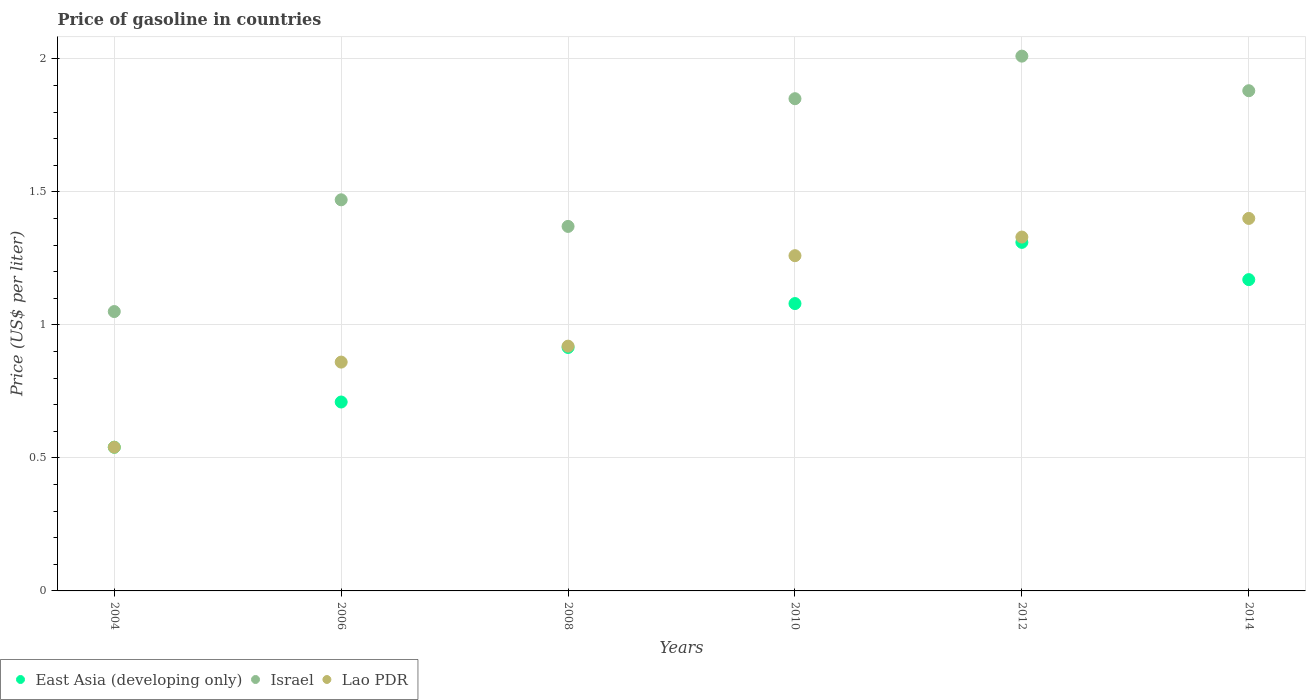How many different coloured dotlines are there?
Offer a terse response. 3. Is the number of dotlines equal to the number of legend labels?
Your answer should be compact. Yes. What is the price of gasoline in Lao PDR in 2014?
Provide a short and direct response. 1.4. Across all years, what is the maximum price of gasoline in Israel?
Offer a terse response. 2.01. In which year was the price of gasoline in East Asia (developing only) maximum?
Ensure brevity in your answer.  2012. In which year was the price of gasoline in East Asia (developing only) minimum?
Provide a succinct answer. 2004. What is the total price of gasoline in Lao PDR in the graph?
Keep it short and to the point. 6.31. What is the difference between the price of gasoline in East Asia (developing only) in 2012 and that in 2014?
Provide a succinct answer. 0.14. What is the difference between the price of gasoline in Lao PDR in 2006 and the price of gasoline in East Asia (developing only) in 2012?
Provide a short and direct response. -0.45. What is the average price of gasoline in Israel per year?
Ensure brevity in your answer.  1.6. In the year 2014, what is the difference between the price of gasoline in East Asia (developing only) and price of gasoline in Lao PDR?
Offer a very short reply. -0.23. What is the ratio of the price of gasoline in Lao PDR in 2006 to that in 2012?
Your response must be concise. 0.65. Is the difference between the price of gasoline in East Asia (developing only) in 2006 and 2014 greater than the difference between the price of gasoline in Lao PDR in 2006 and 2014?
Provide a succinct answer. Yes. What is the difference between the highest and the second highest price of gasoline in Israel?
Ensure brevity in your answer.  0.13. What is the difference between the highest and the lowest price of gasoline in Israel?
Ensure brevity in your answer.  0.96. Is it the case that in every year, the sum of the price of gasoline in East Asia (developing only) and price of gasoline in Lao PDR  is greater than the price of gasoline in Israel?
Give a very brief answer. Yes. Does the price of gasoline in Lao PDR monotonically increase over the years?
Provide a short and direct response. Yes. Is the price of gasoline in East Asia (developing only) strictly greater than the price of gasoline in Israel over the years?
Ensure brevity in your answer.  No. Is the price of gasoline in Lao PDR strictly less than the price of gasoline in East Asia (developing only) over the years?
Offer a very short reply. No. How many years are there in the graph?
Your answer should be very brief. 6. What is the difference between two consecutive major ticks on the Y-axis?
Make the answer very short. 0.5. Does the graph contain grids?
Your answer should be very brief. Yes. How many legend labels are there?
Your answer should be very brief. 3. How are the legend labels stacked?
Provide a short and direct response. Horizontal. What is the title of the graph?
Keep it short and to the point. Price of gasoline in countries. Does "Guinea-Bissau" appear as one of the legend labels in the graph?
Offer a terse response. No. What is the label or title of the X-axis?
Your answer should be very brief. Years. What is the label or title of the Y-axis?
Keep it short and to the point. Price (US$ per liter). What is the Price (US$ per liter) of East Asia (developing only) in 2004?
Your response must be concise. 0.54. What is the Price (US$ per liter) of Israel in 2004?
Give a very brief answer. 1.05. What is the Price (US$ per liter) in Lao PDR in 2004?
Provide a succinct answer. 0.54. What is the Price (US$ per liter) in East Asia (developing only) in 2006?
Keep it short and to the point. 0.71. What is the Price (US$ per liter) in Israel in 2006?
Your response must be concise. 1.47. What is the Price (US$ per liter) of Lao PDR in 2006?
Provide a short and direct response. 0.86. What is the Price (US$ per liter) in East Asia (developing only) in 2008?
Provide a short and direct response. 0.92. What is the Price (US$ per liter) in Israel in 2008?
Give a very brief answer. 1.37. What is the Price (US$ per liter) of East Asia (developing only) in 2010?
Ensure brevity in your answer.  1.08. What is the Price (US$ per liter) of Israel in 2010?
Your answer should be very brief. 1.85. What is the Price (US$ per liter) of Lao PDR in 2010?
Ensure brevity in your answer.  1.26. What is the Price (US$ per liter) in East Asia (developing only) in 2012?
Keep it short and to the point. 1.31. What is the Price (US$ per liter) of Israel in 2012?
Provide a succinct answer. 2.01. What is the Price (US$ per liter) in Lao PDR in 2012?
Provide a short and direct response. 1.33. What is the Price (US$ per liter) in East Asia (developing only) in 2014?
Provide a succinct answer. 1.17. What is the Price (US$ per liter) in Israel in 2014?
Provide a succinct answer. 1.88. Across all years, what is the maximum Price (US$ per liter) of East Asia (developing only)?
Provide a succinct answer. 1.31. Across all years, what is the maximum Price (US$ per liter) of Israel?
Your response must be concise. 2.01. Across all years, what is the minimum Price (US$ per liter) of East Asia (developing only)?
Offer a very short reply. 0.54. Across all years, what is the minimum Price (US$ per liter) of Lao PDR?
Offer a very short reply. 0.54. What is the total Price (US$ per liter) of East Asia (developing only) in the graph?
Make the answer very short. 5.72. What is the total Price (US$ per liter) of Israel in the graph?
Make the answer very short. 9.63. What is the total Price (US$ per liter) in Lao PDR in the graph?
Make the answer very short. 6.31. What is the difference between the Price (US$ per liter) of East Asia (developing only) in 2004 and that in 2006?
Offer a terse response. -0.17. What is the difference between the Price (US$ per liter) in Israel in 2004 and that in 2006?
Provide a succinct answer. -0.42. What is the difference between the Price (US$ per liter) in Lao PDR in 2004 and that in 2006?
Give a very brief answer. -0.32. What is the difference between the Price (US$ per liter) of East Asia (developing only) in 2004 and that in 2008?
Your response must be concise. -0.38. What is the difference between the Price (US$ per liter) in Israel in 2004 and that in 2008?
Your answer should be very brief. -0.32. What is the difference between the Price (US$ per liter) in Lao PDR in 2004 and that in 2008?
Keep it short and to the point. -0.38. What is the difference between the Price (US$ per liter) of East Asia (developing only) in 2004 and that in 2010?
Your answer should be compact. -0.54. What is the difference between the Price (US$ per liter) in Israel in 2004 and that in 2010?
Ensure brevity in your answer.  -0.8. What is the difference between the Price (US$ per liter) of Lao PDR in 2004 and that in 2010?
Provide a succinct answer. -0.72. What is the difference between the Price (US$ per liter) in East Asia (developing only) in 2004 and that in 2012?
Provide a short and direct response. -0.77. What is the difference between the Price (US$ per liter) in Israel in 2004 and that in 2012?
Ensure brevity in your answer.  -0.96. What is the difference between the Price (US$ per liter) in Lao PDR in 2004 and that in 2012?
Your response must be concise. -0.79. What is the difference between the Price (US$ per liter) of East Asia (developing only) in 2004 and that in 2014?
Give a very brief answer. -0.63. What is the difference between the Price (US$ per liter) in Israel in 2004 and that in 2014?
Your response must be concise. -0.83. What is the difference between the Price (US$ per liter) of Lao PDR in 2004 and that in 2014?
Offer a terse response. -0.86. What is the difference between the Price (US$ per liter) of East Asia (developing only) in 2006 and that in 2008?
Keep it short and to the point. -0.2. What is the difference between the Price (US$ per liter) in Lao PDR in 2006 and that in 2008?
Give a very brief answer. -0.06. What is the difference between the Price (US$ per liter) in East Asia (developing only) in 2006 and that in 2010?
Your answer should be very brief. -0.37. What is the difference between the Price (US$ per liter) in Israel in 2006 and that in 2010?
Provide a short and direct response. -0.38. What is the difference between the Price (US$ per liter) of Israel in 2006 and that in 2012?
Your response must be concise. -0.54. What is the difference between the Price (US$ per liter) in Lao PDR in 2006 and that in 2012?
Your answer should be compact. -0.47. What is the difference between the Price (US$ per liter) of East Asia (developing only) in 2006 and that in 2014?
Your answer should be compact. -0.46. What is the difference between the Price (US$ per liter) of Israel in 2006 and that in 2014?
Provide a short and direct response. -0.41. What is the difference between the Price (US$ per liter) of Lao PDR in 2006 and that in 2014?
Provide a short and direct response. -0.54. What is the difference between the Price (US$ per liter) of East Asia (developing only) in 2008 and that in 2010?
Your response must be concise. -0.17. What is the difference between the Price (US$ per liter) of Israel in 2008 and that in 2010?
Your response must be concise. -0.48. What is the difference between the Price (US$ per liter) in Lao PDR in 2008 and that in 2010?
Provide a succinct answer. -0.34. What is the difference between the Price (US$ per liter) in East Asia (developing only) in 2008 and that in 2012?
Give a very brief answer. -0.4. What is the difference between the Price (US$ per liter) of Israel in 2008 and that in 2012?
Offer a terse response. -0.64. What is the difference between the Price (US$ per liter) of Lao PDR in 2008 and that in 2012?
Make the answer very short. -0.41. What is the difference between the Price (US$ per liter) in East Asia (developing only) in 2008 and that in 2014?
Ensure brevity in your answer.  -0.26. What is the difference between the Price (US$ per liter) of Israel in 2008 and that in 2014?
Offer a terse response. -0.51. What is the difference between the Price (US$ per liter) in Lao PDR in 2008 and that in 2014?
Keep it short and to the point. -0.48. What is the difference between the Price (US$ per liter) in East Asia (developing only) in 2010 and that in 2012?
Ensure brevity in your answer.  -0.23. What is the difference between the Price (US$ per liter) in Israel in 2010 and that in 2012?
Your response must be concise. -0.16. What is the difference between the Price (US$ per liter) of Lao PDR in 2010 and that in 2012?
Provide a short and direct response. -0.07. What is the difference between the Price (US$ per liter) in East Asia (developing only) in 2010 and that in 2014?
Your answer should be compact. -0.09. What is the difference between the Price (US$ per liter) of Israel in 2010 and that in 2014?
Offer a very short reply. -0.03. What is the difference between the Price (US$ per liter) of Lao PDR in 2010 and that in 2014?
Provide a succinct answer. -0.14. What is the difference between the Price (US$ per liter) of East Asia (developing only) in 2012 and that in 2014?
Keep it short and to the point. 0.14. What is the difference between the Price (US$ per liter) in Israel in 2012 and that in 2014?
Offer a very short reply. 0.13. What is the difference between the Price (US$ per liter) of Lao PDR in 2012 and that in 2014?
Your answer should be compact. -0.07. What is the difference between the Price (US$ per liter) of East Asia (developing only) in 2004 and the Price (US$ per liter) of Israel in 2006?
Provide a succinct answer. -0.93. What is the difference between the Price (US$ per liter) in East Asia (developing only) in 2004 and the Price (US$ per liter) in Lao PDR in 2006?
Your answer should be very brief. -0.32. What is the difference between the Price (US$ per liter) of Israel in 2004 and the Price (US$ per liter) of Lao PDR in 2006?
Your answer should be compact. 0.19. What is the difference between the Price (US$ per liter) of East Asia (developing only) in 2004 and the Price (US$ per liter) of Israel in 2008?
Give a very brief answer. -0.83. What is the difference between the Price (US$ per liter) in East Asia (developing only) in 2004 and the Price (US$ per liter) in Lao PDR in 2008?
Make the answer very short. -0.38. What is the difference between the Price (US$ per liter) in Israel in 2004 and the Price (US$ per liter) in Lao PDR in 2008?
Offer a very short reply. 0.13. What is the difference between the Price (US$ per liter) in East Asia (developing only) in 2004 and the Price (US$ per liter) in Israel in 2010?
Your answer should be compact. -1.31. What is the difference between the Price (US$ per liter) in East Asia (developing only) in 2004 and the Price (US$ per liter) in Lao PDR in 2010?
Offer a very short reply. -0.72. What is the difference between the Price (US$ per liter) in Israel in 2004 and the Price (US$ per liter) in Lao PDR in 2010?
Your answer should be compact. -0.21. What is the difference between the Price (US$ per liter) in East Asia (developing only) in 2004 and the Price (US$ per liter) in Israel in 2012?
Keep it short and to the point. -1.47. What is the difference between the Price (US$ per liter) of East Asia (developing only) in 2004 and the Price (US$ per liter) of Lao PDR in 2012?
Your response must be concise. -0.79. What is the difference between the Price (US$ per liter) in Israel in 2004 and the Price (US$ per liter) in Lao PDR in 2012?
Give a very brief answer. -0.28. What is the difference between the Price (US$ per liter) of East Asia (developing only) in 2004 and the Price (US$ per liter) of Israel in 2014?
Make the answer very short. -1.34. What is the difference between the Price (US$ per liter) in East Asia (developing only) in 2004 and the Price (US$ per liter) in Lao PDR in 2014?
Keep it short and to the point. -0.86. What is the difference between the Price (US$ per liter) in Israel in 2004 and the Price (US$ per liter) in Lao PDR in 2014?
Make the answer very short. -0.35. What is the difference between the Price (US$ per liter) in East Asia (developing only) in 2006 and the Price (US$ per liter) in Israel in 2008?
Your answer should be compact. -0.66. What is the difference between the Price (US$ per liter) of East Asia (developing only) in 2006 and the Price (US$ per liter) of Lao PDR in 2008?
Your answer should be compact. -0.21. What is the difference between the Price (US$ per liter) in Israel in 2006 and the Price (US$ per liter) in Lao PDR in 2008?
Provide a succinct answer. 0.55. What is the difference between the Price (US$ per liter) in East Asia (developing only) in 2006 and the Price (US$ per liter) in Israel in 2010?
Your answer should be very brief. -1.14. What is the difference between the Price (US$ per liter) of East Asia (developing only) in 2006 and the Price (US$ per liter) of Lao PDR in 2010?
Give a very brief answer. -0.55. What is the difference between the Price (US$ per liter) in Israel in 2006 and the Price (US$ per liter) in Lao PDR in 2010?
Your answer should be very brief. 0.21. What is the difference between the Price (US$ per liter) in East Asia (developing only) in 2006 and the Price (US$ per liter) in Israel in 2012?
Make the answer very short. -1.3. What is the difference between the Price (US$ per liter) in East Asia (developing only) in 2006 and the Price (US$ per liter) in Lao PDR in 2012?
Keep it short and to the point. -0.62. What is the difference between the Price (US$ per liter) of Israel in 2006 and the Price (US$ per liter) of Lao PDR in 2012?
Provide a short and direct response. 0.14. What is the difference between the Price (US$ per liter) of East Asia (developing only) in 2006 and the Price (US$ per liter) of Israel in 2014?
Ensure brevity in your answer.  -1.17. What is the difference between the Price (US$ per liter) in East Asia (developing only) in 2006 and the Price (US$ per liter) in Lao PDR in 2014?
Your response must be concise. -0.69. What is the difference between the Price (US$ per liter) of Israel in 2006 and the Price (US$ per liter) of Lao PDR in 2014?
Offer a very short reply. 0.07. What is the difference between the Price (US$ per liter) in East Asia (developing only) in 2008 and the Price (US$ per liter) in Israel in 2010?
Offer a very short reply. -0.94. What is the difference between the Price (US$ per liter) of East Asia (developing only) in 2008 and the Price (US$ per liter) of Lao PDR in 2010?
Make the answer very short. -0.34. What is the difference between the Price (US$ per liter) in Israel in 2008 and the Price (US$ per liter) in Lao PDR in 2010?
Provide a short and direct response. 0.11. What is the difference between the Price (US$ per liter) of East Asia (developing only) in 2008 and the Price (US$ per liter) of Israel in 2012?
Make the answer very short. -1.09. What is the difference between the Price (US$ per liter) of East Asia (developing only) in 2008 and the Price (US$ per liter) of Lao PDR in 2012?
Make the answer very short. -0.41. What is the difference between the Price (US$ per liter) of East Asia (developing only) in 2008 and the Price (US$ per liter) of Israel in 2014?
Your response must be concise. -0.96. What is the difference between the Price (US$ per liter) in East Asia (developing only) in 2008 and the Price (US$ per liter) in Lao PDR in 2014?
Provide a short and direct response. -0.48. What is the difference between the Price (US$ per liter) of Israel in 2008 and the Price (US$ per liter) of Lao PDR in 2014?
Your answer should be very brief. -0.03. What is the difference between the Price (US$ per liter) of East Asia (developing only) in 2010 and the Price (US$ per liter) of Israel in 2012?
Make the answer very short. -0.93. What is the difference between the Price (US$ per liter) in East Asia (developing only) in 2010 and the Price (US$ per liter) in Lao PDR in 2012?
Give a very brief answer. -0.25. What is the difference between the Price (US$ per liter) in Israel in 2010 and the Price (US$ per liter) in Lao PDR in 2012?
Provide a succinct answer. 0.52. What is the difference between the Price (US$ per liter) of East Asia (developing only) in 2010 and the Price (US$ per liter) of Israel in 2014?
Keep it short and to the point. -0.8. What is the difference between the Price (US$ per liter) in East Asia (developing only) in 2010 and the Price (US$ per liter) in Lao PDR in 2014?
Give a very brief answer. -0.32. What is the difference between the Price (US$ per liter) of Israel in 2010 and the Price (US$ per liter) of Lao PDR in 2014?
Offer a terse response. 0.45. What is the difference between the Price (US$ per liter) in East Asia (developing only) in 2012 and the Price (US$ per liter) in Israel in 2014?
Your answer should be very brief. -0.57. What is the difference between the Price (US$ per liter) in East Asia (developing only) in 2012 and the Price (US$ per liter) in Lao PDR in 2014?
Make the answer very short. -0.09. What is the difference between the Price (US$ per liter) in Israel in 2012 and the Price (US$ per liter) in Lao PDR in 2014?
Give a very brief answer. 0.61. What is the average Price (US$ per liter) in East Asia (developing only) per year?
Keep it short and to the point. 0.95. What is the average Price (US$ per liter) of Israel per year?
Provide a short and direct response. 1.6. What is the average Price (US$ per liter) in Lao PDR per year?
Your answer should be compact. 1.05. In the year 2004, what is the difference between the Price (US$ per liter) in East Asia (developing only) and Price (US$ per liter) in Israel?
Make the answer very short. -0.51. In the year 2004, what is the difference between the Price (US$ per liter) in Israel and Price (US$ per liter) in Lao PDR?
Make the answer very short. 0.51. In the year 2006, what is the difference between the Price (US$ per liter) of East Asia (developing only) and Price (US$ per liter) of Israel?
Keep it short and to the point. -0.76. In the year 2006, what is the difference between the Price (US$ per liter) of East Asia (developing only) and Price (US$ per liter) of Lao PDR?
Offer a very short reply. -0.15. In the year 2006, what is the difference between the Price (US$ per liter) in Israel and Price (US$ per liter) in Lao PDR?
Provide a succinct answer. 0.61. In the year 2008, what is the difference between the Price (US$ per liter) in East Asia (developing only) and Price (US$ per liter) in Israel?
Keep it short and to the point. -0.46. In the year 2008, what is the difference between the Price (US$ per liter) in East Asia (developing only) and Price (US$ per liter) in Lao PDR?
Provide a succinct answer. -0.01. In the year 2008, what is the difference between the Price (US$ per liter) of Israel and Price (US$ per liter) of Lao PDR?
Give a very brief answer. 0.45. In the year 2010, what is the difference between the Price (US$ per liter) in East Asia (developing only) and Price (US$ per liter) in Israel?
Ensure brevity in your answer.  -0.77. In the year 2010, what is the difference between the Price (US$ per liter) in East Asia (developing only) and Price (US$ per liter) in Lao PDR?
Ensure brevity in your answer.  -0.18. In the year 2010, what is the difference between the Price (US$ per liter) of Israel and Price (US$ per liter) of Lao PDR?
Give a very brief answer. 0.59. In the year 2012, what is the difference between the Price (US$ per liter) in East Asia (developing only) and Price (US$ per liter) in Lao PDR?
Your answer should be very brief. -0.02. In the year 2012, what is the difference between the Price (US$ per liter) in Israel and Price (US$ per liter) in Lao PDR?
Your answer should be compact. 0.68. In the year 2014, what is the difference between the Price (US$ per liter) in East Asia (developing only) and Price (US$ per liter) in Israel?
Your answer should be very brief. -0.71. In the year 2014, what is the difference between the Price (US$ per liter) in East Asia (developing only) and Price (US$ per liter) in Lao PDR?
Provide a short and direct response. -0.23. In the year 2014, what is the difference between the Price (US$ per liter) in Israel and Price (US$ per liter) in Lao PDR?
Offer a very short reply. 0.48. What is the ratio of the Price (US$ per liter) of East Asia (developing only) in 2004 to that in 2006?
Offer a terse response. 0.76. What is the ratio of the Price (US$ per liter) of Israel in 2004 to that in 2006?
Your answer should be very brief. 0.71. What is the ratio of the Price (US$ per liter) in Lao PDR in 2004 to that in 2006?
Your answer should be very brief. 0.63. What is the ratio of the Price (US$ per liter) in East Asia (developing only) in 2004 to that in 2008?
Your answer should be compact. 0.59. What is the ratio of the Price (US$ per liter) in Israel in 2004 to that in 2008?
Give a very brief answer. 0.77. What is the ratio of the Price (US$ per liter) in Lao PDR in 2004 to that in 2008?
Provide a short and direct response. 0.59. What is the ratio of the Price (US$ per liter) of East Asia (developing only) in 2004 to that in 2010?
Ensure brevity in your answer.  0.5. What is the ratio of the Price (US$ per liter) in Israel in 2004 to that in 2010?
Ensure brevity in your answer.  0.57. What is the ratio of the Price (US$ per liter) in Lao PDR in 2004 to that in 2010?
Ensure brevity in your answer.  0.43. What is the ratio of the Price (US$ per liter) of East Asia (developing only) in 2004 to that in 2012?
Ensure brevity in your answer.  0.41. What is the ratio of the Price (US$ per liter) in Israel in 2004 to that in 2012?
Your answer should be very brief. 0.52. What is the ratio of the Price (US$ per liter) of Lao PDR in 2004 to that in 2012?
Your answer should be compact. 0.41. What is the ratio of the Price (US$ per liter) of East Asia (developing only) in 2004 to that in 2014?
Ensure brevity in your answer.  0.46. What is the ratio of the Price (US$ per liter) of Israel in 2004 to that in 2014?
Your answer should be very brief. 0.56. What is the ratio of the Price (US$ per liter) in Lao PDR in 2004 to that in 2014?
Your response must be concise. 0.39. What is the ratio of the Price (US$ per liter) in East Asia (developing only) in 2006 to that in 2008?
Give a very brief answer. 0.78. What is the ratio of the Price (US$ per liter) of Israel in 2006 to that in 2008?
Your answer should be compact. 1.07. What is the ratio of the Price (US$ per liter) of Lao PDR in 2006 to that in 2008?
Ensure brevity in your answer.  0.93. What is the ratio of the Price (US$ per liter) in East Asia (developing only) in 2006 to that in 2010?
Provide a succinct answer. 0.66. What is the ratio of the Price (US$ per liter) in Israel in 2006 to that in 2010?
Provide a succinct answer. 0.79. What is the ratio of the Price (US$ per liter) in Lao PDR in 2006 to that in 2010?
Make the answer very short. 0.68. What is the ratio of the Price (US$ per liter) of East Asia (developing only) in 2006 to that in 2012?
Your answer should be compact. 0.54. What is the ratio of the Price (US$ per liter) of Israel in 2006 to that in 2012?
Provide a succinct answer. 0.73. What is the ratio of the Price (US$ per liter) of Lao PDR in 2006 to that in 2012?
Ensure brevity in your answer.  0.65. What is the ratio of the Price (US$ per liter) in East Asia (developing only) in 2006 to that in 2014?
Your answer should be compact. 0.61. What is the ratio of the Price (US$ per liter) in Israel in 2006 to that in 2014?
Your answer should be very brief. 0.78. What is the ratio of the Price (US$ per liter) of Lao PDR in 2006 to that in 2014?
Your answer should be very brief. 0.61. What is the ratio of the Price (US$ per liter) of East Asia (developing only) in 2008 to that in 2010?
Your answer should be compact. 0.85. What is the ratio of the Price (US$ per liter) in Israel in 2008 to that in 2010?
Offer a terse response. 0.74. What is the ratio of the Price (US$ per liter) in Lao PDR in 2008 to that in 2010?
Provide a succinct answer. 0.73. What is the ratio of the Price (US$ per liter) of East Asia (developing only) in 2008 to that in 2012?
Make the answer very short. 0.7. What is the ratio of the Price (US$ per liter) of Israel in 2008 to that in 2012?
Your answer should be very brief. 0.68. What is the ratio of the Price (US$ per liter) in Lao PDR in 2008 to that in 2012?
Provide a short and direct response. 0.69. What is the ratio of the Price (US$ per liter) of East Asia (developing only) in 2008 to that in 2014?
Your answer should be very brief. 0.78. What is the ratio of the Price (US$ per liter) of Israel in 2008 to that in 2014?
Make the answer very short. 0.73. What is the ratio of the Price (US$ per liter) in Lao PDR in 2008 to that in 2014?
Your response must be concise. 0.66. What is the ratio of the Price (US$ per liter) in East Asia (developing only) in 2010 to that in 2012?
Your answer should be compact. 0.82. What is the ratio of the Price (US$ per liter) of Israel in 2010 to that in 2012?
Make the answer very short. 0.92. What is the ratio of the Price (US$ per liter) in Lao PDR in 2010 to that in 2014?
Provide a short and direct response. 0.9. What is the ratio of the Price (US$ per liter) of East Asia (developing only) in 2012 to that in 2014?
Offer a very short reply. 1.12. What is the ratio of the Price (US$ per liter) in Israel in 2012 to that in 2014?
Your answer should be very brief. 1.07. What is the ratio of the Price (US$ per liter) of Lao PDR in 2012 to that in 2014?
Provide a succinct answer. 0.95. What is the difference between the highest and the second highest Price (US$ per liter) in East Asia (developing only)?
Your response must be concise. 0.14. What is the difference between the highest and the second highest Price (US$ per liter) of Israel?
Give a very brief answer. 0.13. What is the difference between the highest and the second highest Price (US$ per liter) of Lao PDR?
Offer a very short reply. 0.07. What is the difference between the highest and the lowest Price (US$ per liter) of East Asia (developing only)?
Your answer should be compact. 0.77. What is the difference between the highest and the lowest Price (US$ per liter) in Israel?
Offer a terse response. 0.96. What is the difference between the highest and the lowest Price (US$ per liter) of Lao PDR?
Keep it short and to the point. 0.86. 